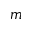Convert formula to latex. <formula><loc_0><loc_0><loc_500><loc_500>m</formula> 